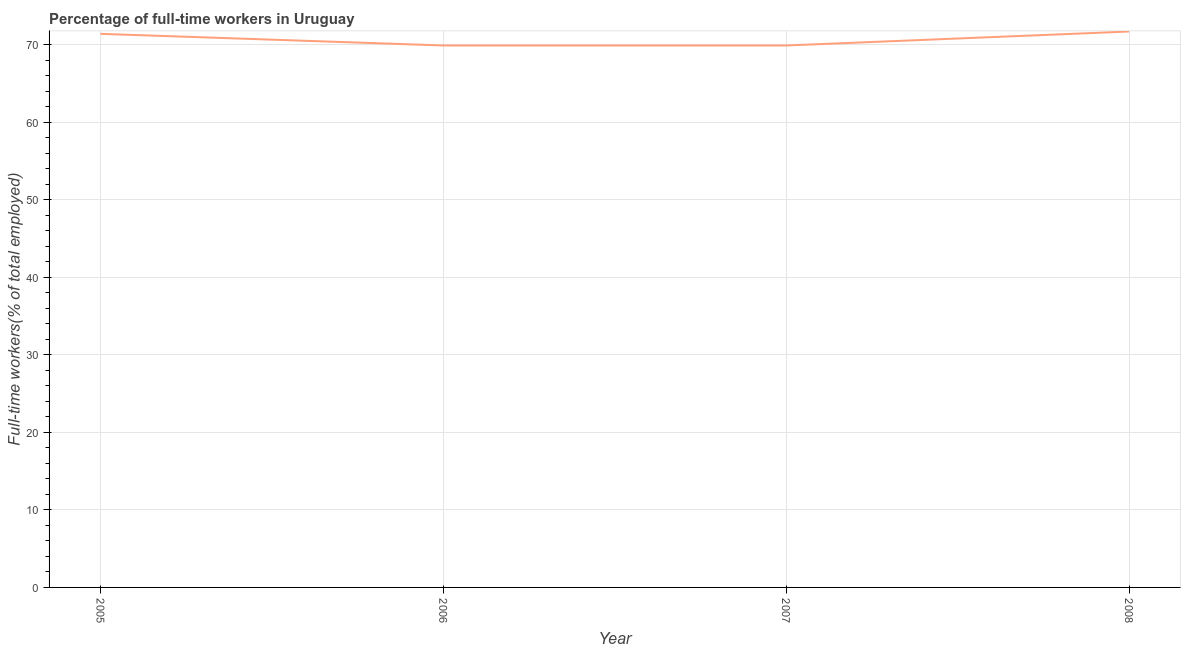What is the percentage of full-time workers in 2008?
Offer a terse response. 71.7. Across all years, what is the maximum percentage of full-time workers?
Your answer should be very brief. 71.7. Across all years, what is the minimum percentage of full-time workers?
Offer a terse response. 69.9. In which year was the percentage of full-time workers maximum?
Your answer should be very brief. 2008. What is the sum of the percentage of full-time workers?
Provide a short and direct response. 282.9. What is the difference between the percentage of full-time workers in 2005 and 2008?
Give a very brief answer. -0.3. What is the average percentage of full-time workers per year?
Keep it short and to the point. 70.73. What is the median percentage of full-time workers?
Make the answer very short. 70.65. In how many years, is the percentage of full-time workers greater than 24 %?
Provide a short and direct response. 4. What is the ratio of the percentage of full-time workers in 2007 to that in 2008?
Your response must be concise. 0.97. Is the percentage of full-time workers in 2006 less than that in 2008?
Provide a succinct answer. Yes. Is the difference between the percentage of full-time workers in 2005 and 2007 greater than the difference between any two years?
Offer a very short reply. No. What is the difference between the highest and the second highest percentage of full-time workers?
Your answer should be very brief. 0.3. What is the difference between the highest and the lowest percentage of full-time workers?
Provide a succinct answer. 1.8. How many lines are there?
Keep it short and to the point. 1. Are the values on the major ticks of Y-axis written in scientific E-notation?
Your response must be concise. No. Does the graph contain any zero values?
Your response must be concise. No. Does the graph contain grids?
Ensure brevity in your answer.  Yes. What is the title of the graph?
Make the answer very short. Percentage of full-time workers in Uruguay. What is the label or title of the X-axis?
Keep it short and to the point. Year. What is the label or title of the Y-axis?
Ensure brevity in your answer.  Full-time workers(% of total employed). What is the Full-time workers(% of total employed) of 2005?
Your answer should be very brief. 71.4. What is the Full-time workers(% of total employed) in 2006?
Offer a very short reply. 69.9. What is the Full-time workers(% of total employed) in 2007?
Ensure brevity in your answer.  69.9. What is the Full-time workers(% of total employed) of 2008?
Your response must be concise. 71.7. What is the difference between the Full-time workers(% of total employed) in 2005 and 2006?
Offer a terse response. 1.5. What is the difference between the Full-time workers(% of total employed) in 2005 and 2007?
Provide a short and direct response. 1.5. What is the difference between the Full-time workers(% of total employed) in 2005 and 2008?
Give a very brief answer. -0.3. What is the difference between the Full-time workers(% of total employed) in 2006 and 2007?
Ensure brevity in your answer.  0. What is the difference between the Full-time workers(% of total employed) in 2006 and 2008?
Keep it short and to the point. -1.8. What is the difference between the Full-time workers(% of total employed) in 2007 and 2008?
Your response must be concise. -1.8. What is the ratio of the Full-time workers(% of total employed) in 2005 to that in 2006?
Your answer should be very brief. 1.02. What is the ratio of the Full-time workers(% of total employed) in 2005 to that in 2007?
Make the answer very short. 1.02. What is the ratio of the Full-time workers(% of total employed) in 2005 to that in 2008?
Provide a succinct answer. 1. What is the ratio of the Full-time workers(% of total employed) in 2006 to that in 2008?
Provide a short and direct response. 0.97. What is the ratio of the Full-time workers(% of total employed) in 2007 to that in 2008?
Provide a short and direct response. 0.97. 